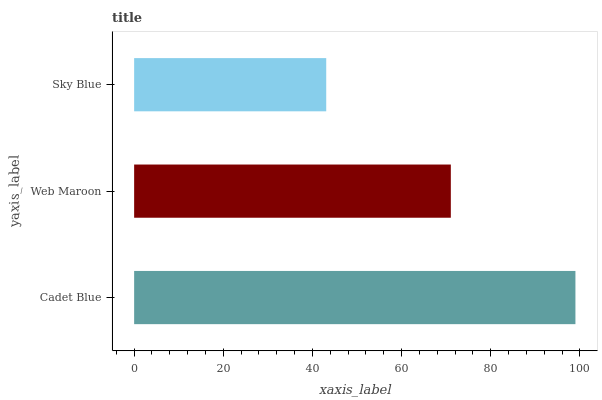Is Sky Blue the minimum?
Answer yes or no. Yes. Is Cadet Blue the maximum?
Answer yes or no. Yes. Is Web Maroon the minimum?
Answer yes or no. No. Is Web Maroon the maximum?
Answer yes or no. No. Is Cadet Blue greater than Web Maroon?
Answer yes or no. Yes. Is Web Maroon less than Cadet Blue?
Answer yes or no. Yes. Is Web Maroon greater than Cadet Blue?
Answer yes or no. No. Is Cadet Blue less than Web Maroon?
Answer yes or no. No. Is Web Maroon the high median?
Answer yes or no. Yes. Is Web Maroon the low median?
Answer yes or no. Yes. Is Cadet Blue the high median?
Answer yes or no. No. Is Cadet Blue the low median?
Answer yes or no. No. 